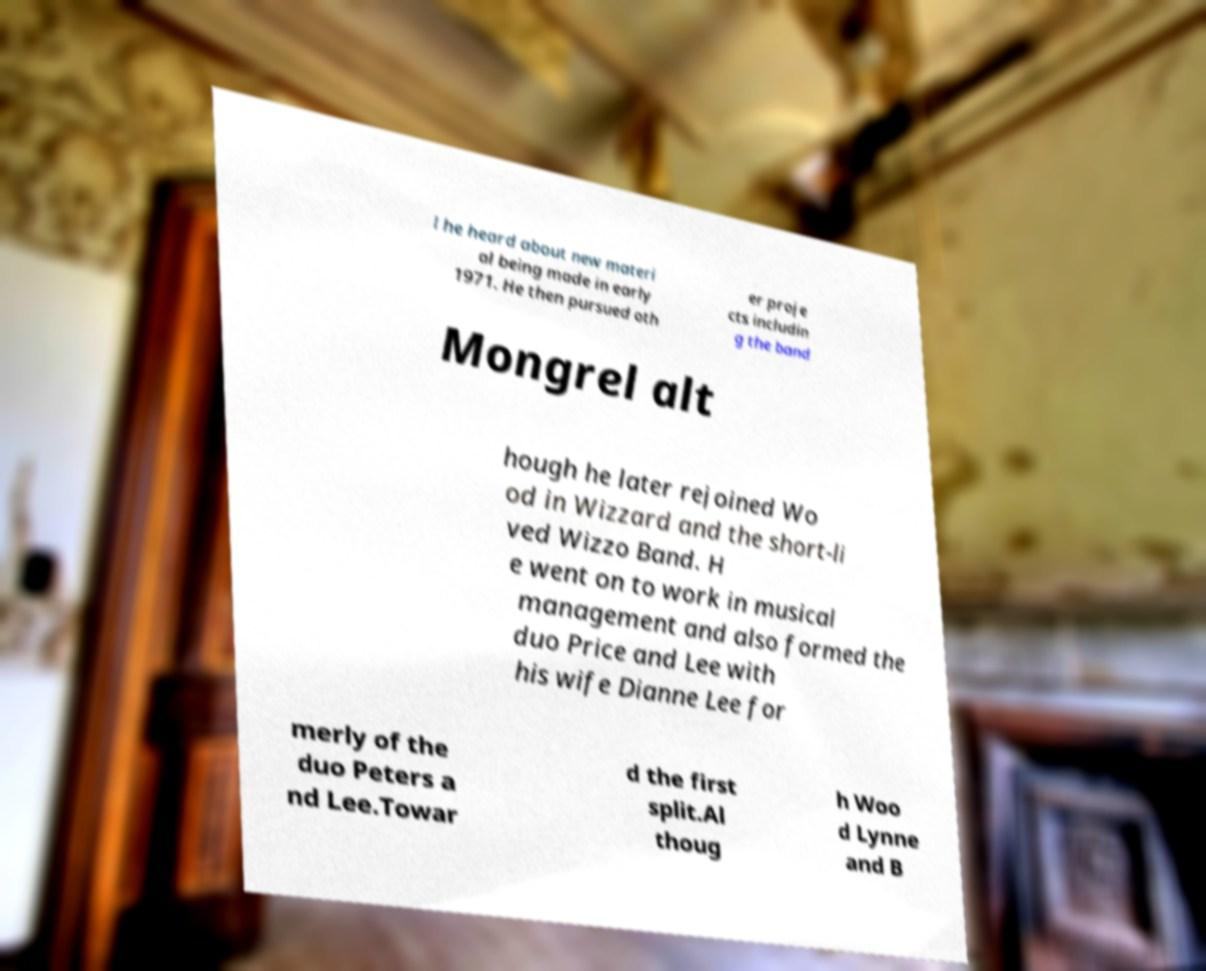Can you accurately transcribe the text from the provided image for me? l he heard about new materi al being made in early 1971. He then pursued oth er proje cts includin g the band Mongrel alt hough he later rejoined Wo od in Wizzard and the short-li ved Wizzo Band. H e went on to work in musical management and also formed the duo Price and Lee with his wife Dianne Lee for merly of the duo Peters a nd Lee.Towar d the first split.Al thoug h Woo d Lynne and B 